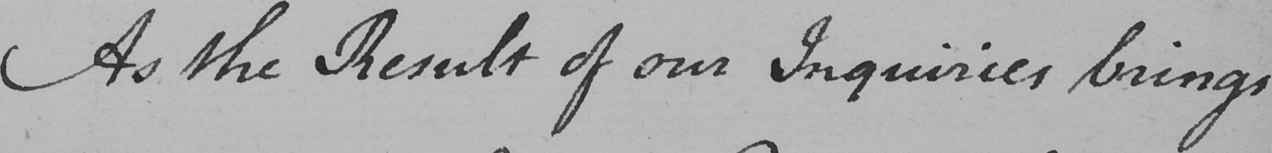Please transcribe the handwritten text in this image. As the Result of our Inquiries brings 